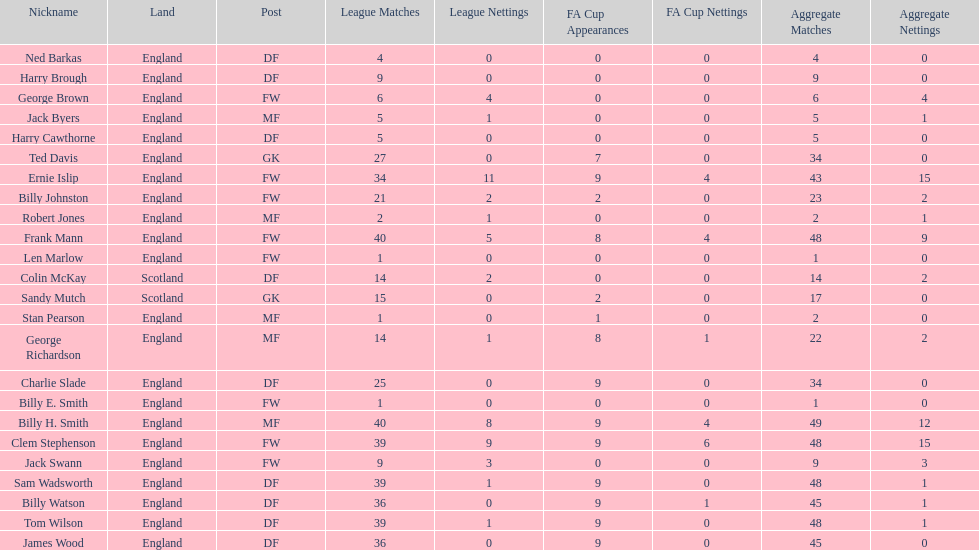Mean count of goals netted by athletes from scotland 1. 